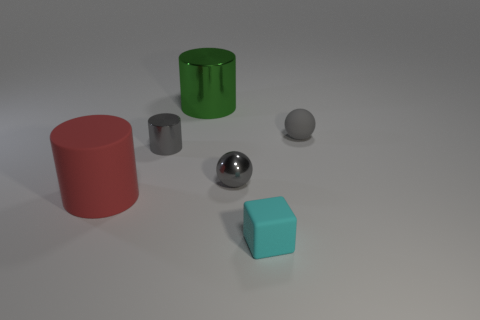Add 4 shiny cylinders. How many objects exist? 10 Subtract all spheres. How many objects are left? 4 Add 3 large green cylinders. How many large green cylinders are left? 4 Add 3 big matte objects. How many big matte objects exist? 4 Subtract 0 purple cylinders. How many objects are left? 6 Subtract all green shiny cylinders. Subtract all gray cylinders. How many objects are left? 4 